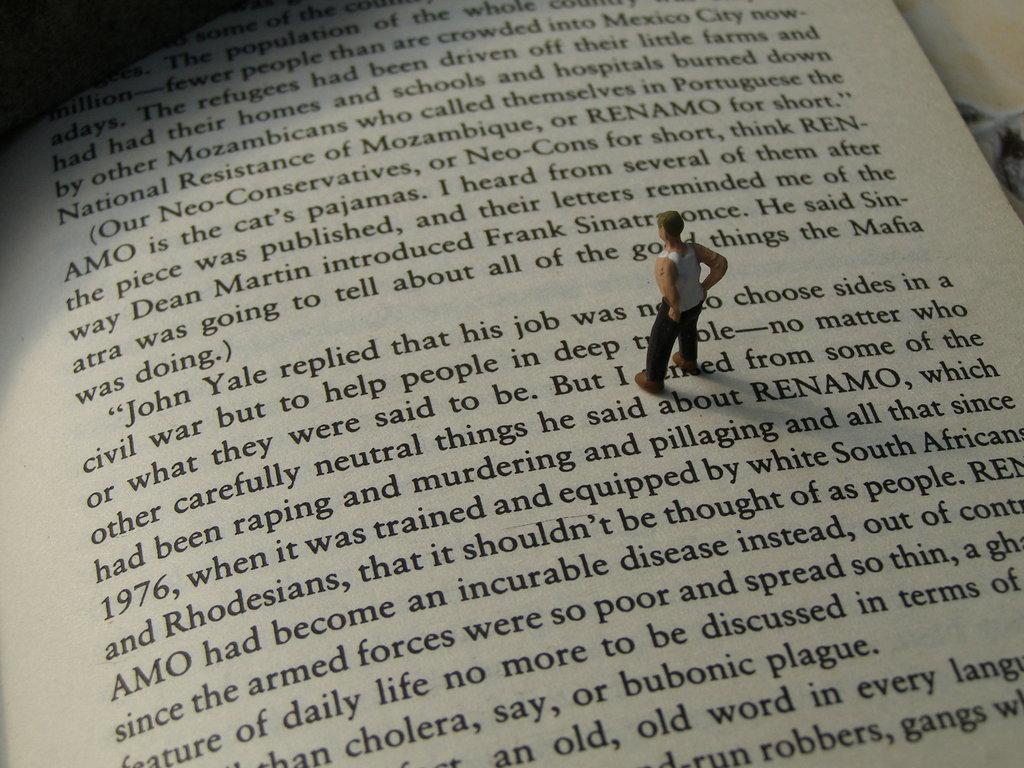<image>
Give a short and clear explanation of the subsequent image. A tiny figure of a man reading a book page about a man named John Yale. 